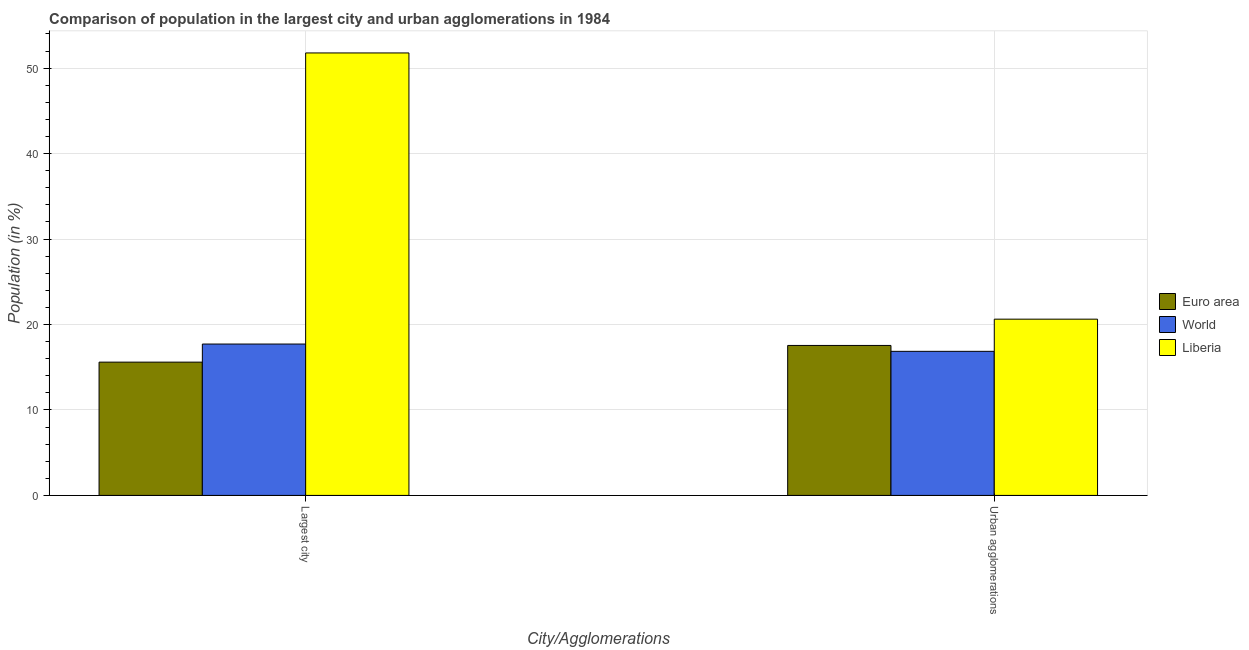How many different coloured bars are there?
Offer a terse response. 3. How many groups of bars are there?
Your answer should be very brief. 2. Are the number of bars on each tick of the X-axis equal?
Your answer should be compact. Yes. How many bars are there on the 1st tick from the right?
Offer a terse response. 3. What is the label of the 2nd group of bars from the left?
Provide a short and direct response. Urban agglomerations. What is the population in the largest city in Liberia?
Offer a terse response. 51.78. Across all countries, what is the maximum population in urban agglomerations?
Your answer should be compact. 20.63. Across all countries, what is the minimum population in the largest city?
Ensure brevity in your answer.  15.6. In which country was the population in the largest city maximum?
Give a very brief answer. Liberia. In which country was the population in the largest city minimum?
Ensure brevity in your answer.  Euro area. What is the total population in the largest city in the graph?
Offer a terse response. 85.1. What is the difference between the population in the largest city in World and that in Euro area?
Offer a very short reply. 2.12. What is the difference between the population in the largest city in Euro area and the population in urban agglomerations in Liberia?
Offer a terse response. -5.03. What is the average population in the largest city per country?
Your response must be concise. 28.37. What is the difference between the population in urban agglomerations and population in the largest city in Liberia?
Your answer should be very brief. -31.16. What is the ratio of the population in the largest city in Liberia to that in World?
Provide a succinct answer. 2.92. Is the population in urban agglomerations in Liberia less than that in Euro area?
Provide a succinct answer. No. In how many countries, is the population in urban agglomerations greater than the average population in urban agglomerations taken over all countries?
Your answer should be very brief. 1. What does the 3rd bar from the right in Largest city represents?
Give a very brief answer. Euro area. How many bars are there?
Your answer should be compact. 6. Are all the bars in the graph horizontal?
Offer a terse response. No. Are the values on the major ticks of Y-axis written in scientific E-notation?
Offer a very short reply. No. Does the graph contain grids?
Keep it short and to the point. Yes. What is the title of the graph?
Your answer should be compact. Comparison of population in the largest city and urban agglomerations in 1984. Does "Korea (Democratic)" appear as one of the legend labels in the graph?
Keep it short and to the point. No. What is the label or title of the X-axis?
Your answer should be compact. City/Agglomerations. What is the label or title of the Y-axis?
Provide a short and direct response. Population (in %). What is the Population (in %) of Euro area in Largest city?
Your answer should be very brief. 15.6. What is the Population (in %) of World in Largest city?
Your answer should be very brief. 17.72. What is the Population (in %) of Liberia in Largest city?
Your answer should be very brief. 51.78. What is the Population (in %) of Euro area in Urban agglomerations?
Give a very brief answer. 17.55. What is the Population (in %) of World in Urban agglomerations?
Make the answer very short. 16.86. What is the Population (in %) in Liberia in Urban agglomerations?
Keep it short and to the point. 20.63. Across all City/Agglomerations, what is the maximum Population (in %) in Euro area?
Your response must be concise. 17.55. Across all City/Agglomerations, what is the maximum Population (in %) of World?
Offer a very short reply. 17.72. Across all City/Agglomerations, what is the maximum Population (in %) of Liberia?
Your response must be concise. 51.78. Across all City/Agglomerations, what is the minimum Population (in %) in Euro area?
Make the answer very short. 15.6. Across all City/Agglomerations, what is the minimum Population (in %) in World?
Make the answer very short. 16.86. Across all City/Agglomerations, what is the minimum Population (in %) in Liberia?
Keep it short and to the point. 20.63. What is the total Population (in %) in Euro area in the graph?
Offer a terse response. 33.15. What is the total Population (in %) in World in the graph?
Offer a very short reply. 34.58. What is the total Population (in %) in Liberia in the graph?
Your answer should be compact. 72.41. What is the difference between the Population (in %) of Euro area in Largest city and that in Urban agglomerations?
Provide a short and direct response. -1.95. What is the difference between the Population (in %) of World in Largest city and that in Urban agglomerations?
Offer a terse response. 0.85. What is the difference between the Population (in %) in Liberia in Largest city and that in Urban agglomerations?
Your response must be concise. 31.16. What is the difference between the Population (in %) of Euro area in Largest city and the Population (in %) of World in Urban agglomerations?
Ensure brevity in your answer.  -1.26. What is the difference between the Population (in %) of Euro area in Largest city and the Population (in %) of Liberia in Urban agglomerations?
Provide a short and direct response. -5.03. What is the difference between the Population (in %) of World in Largest city and the Population (in %) of Liberia in Urban agglomerations?
Your response must be concise. -2.91. What is the average Population (in %) of Euro area per City/Agglomerations?
Your answer should be very brief. 16.57. What is the average Population (in %) of World per City/Agglomerations?
Give a very brief answer. 17.29. What is the average Population (in %) of Liberia per City/Agglomerations?
Your answer should be very brief. 36.2. What is the difference between the Population (in %) of Euro area and Population (in %) of World in Largest city?
Your response must be concise. -2.12. What is the difference between the Population (in %) of Euro area and Population (in %) of Liberia in Largest city?
Make the answer very short. -36.18. What is the difference between the Population (in %) in World and Population (in %) in Liberia in Largest city?
Offer a very short reply. -34.07. What is the difference between the Population (in %) of Euro area and Population (in %) of World in Urban agglomerations?
Make the answer very short. 0.69. What is the difference between the Population (in %) of Euro area and Population (in %) of Liberia in Urban agglomerations?
Your response must be concise. -3.08. What is the difference between the Population (in %) of World and Population (in %) of Liberia in Urban agglomerations?
Offer a terse response. -3.77. What is the ratio of the Population (in %) of Euro area in Largest city to that in Urban agglomerations?
Provide a short and direct response. 0.89. What is the ratio of the Population (in %) in World in Largest city to that in Urban agglomerations?
Ensure brevity in your answer.  1.05. What is the ratio of the Population (in %) in Liberia in Largest city to that in Urban agglomerations?
Your answer should be compact. 2.51. What is the difference between the highest and the second highest Population (in %) in Euro area?
Keep it short and to the point. 1.95. What is the difference between the highest and the second highest Population (in %) of World?
Ensure brevity in your answer.  0.85. What is the difference between the highest and the second highest Population (in %) of Liberia?
Your response must be concise. 31.16. What is the difference between the highest and the lowest Population (in %) in Euro area?
Your answer should be compact. 1.95. What is the difference between the highest and the lowest Population (in %) of World?
Provide a short and direct response. 0.85. What is the difference between the highest and the lowest Population (in %) in Liberia?
Keep it short and to the point. 31.16. 